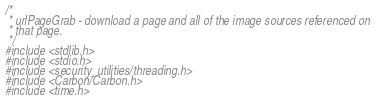<code> <loc_0><loc_0><loc_500><loc_500><_C++_>/*
 * urlPageGrab - download a page and all of the image sources referenced on 
 * that page.
 */
#include <stdlib.h>
#include <stdio.h>
#include <security_utilities/threading.h>
#include <Carbon/Carbon.h>
#include <time.h></code> 